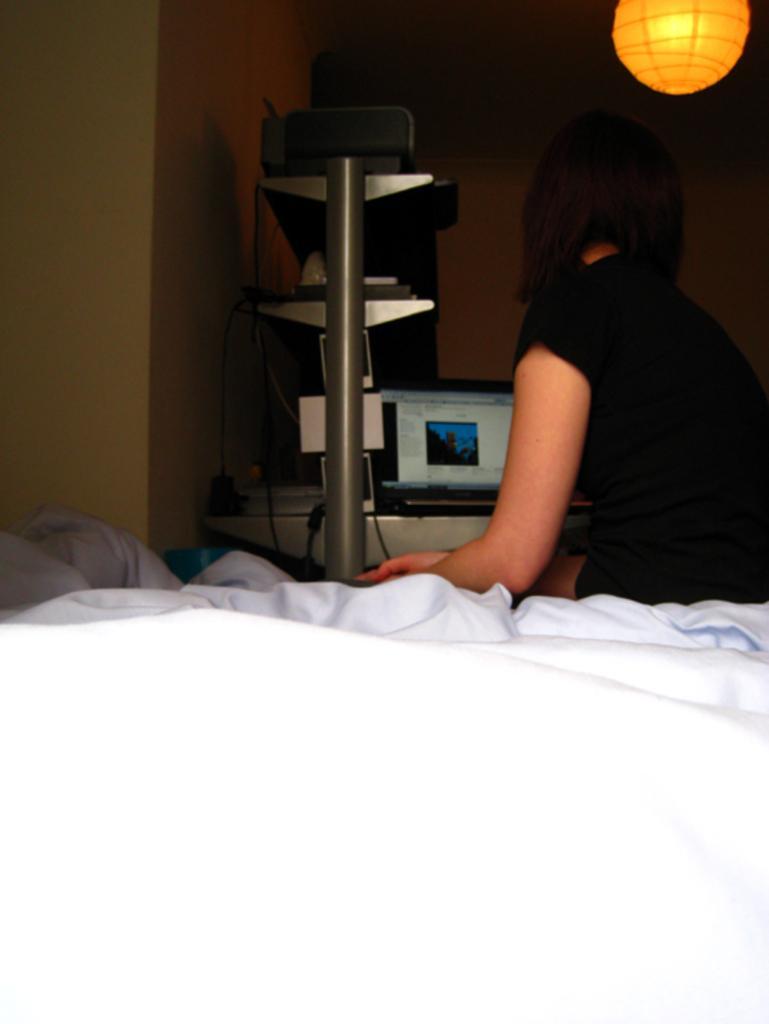How would you summarize this image in a sentence or two? In the foreground of this picture we can see a white color object seems to be the bed and we can see a person wearing black color dress and sitting on the bed. In the background we can see the wall, light, laptop and some other objects and a table. 